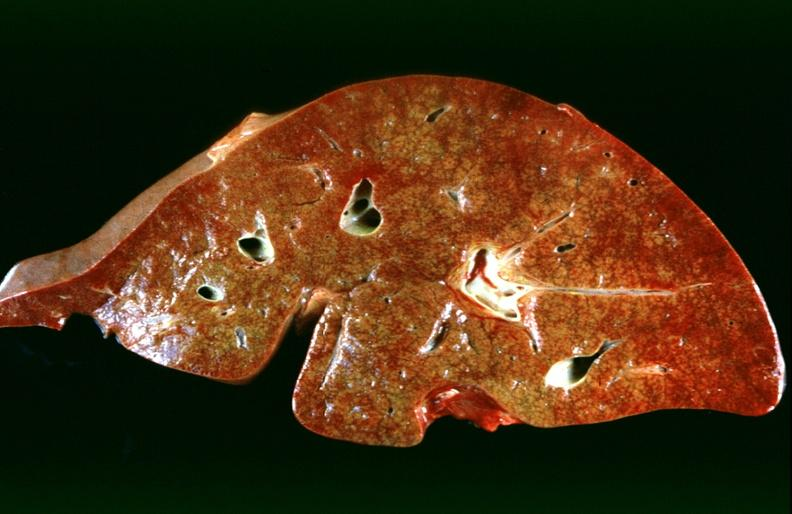s adenocarcinoma present?
Answer the question using a single word or phrase. No 